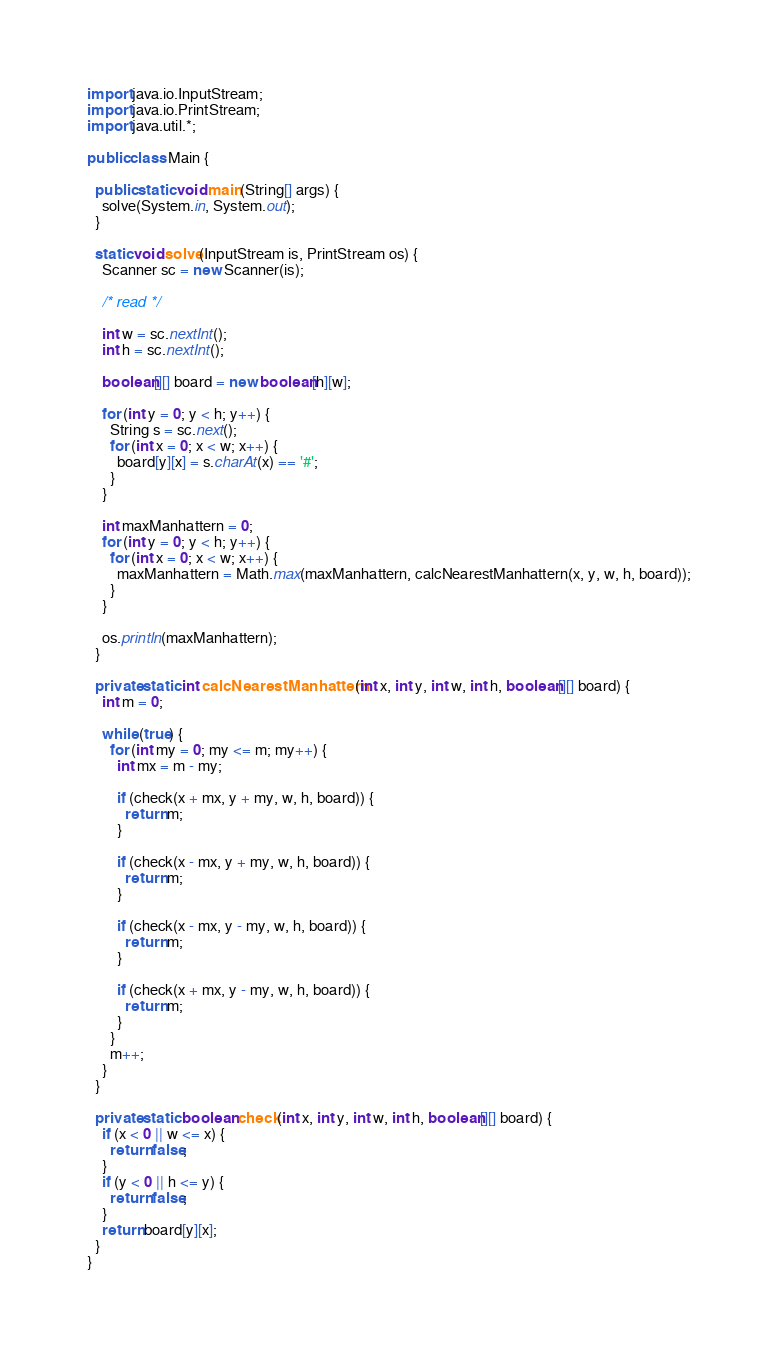<code> <loc_0><loc_0><loc_500><loc_500><_Java_>import java.io.InputStream;
import java.io.PrintStream;
import java.util.*;

public class Main {

  public static void main(String[] args) {
    solve(System.in, System.out);
  }

  static void solve(InputStream is, PrintStream os) {
    Scanner sc = new Scanner(is);

    /* read */

    int w = sc.nextInt();
    int h = sc.nextInt();

    boolean[][] board = new boolean[h][w];

    for (int y = 0; y < h; y++) {
      String s = sc.next();
      for (int x = 0; x < w; x++) {
        board[y][x] = s.charAt(x) == '#';
      }
    }

    int maxManhattern = 0;
    for (int y = 0; y < h; y++) {
      for (int x = 0; x < w; x++) {
        maxManhattern = Math.max(maxManhattern, calcNearestManhattern(x, y, w, h, board));
      }
    }

    os.println(maxManhattern);
  }

  private static int calcNearestManhattern(int x, int y, int w, int h, boolean[][] board) {
    int m = 0;

    while (true) {
      for (int my = 0; my <= m; my++) {
        int mx = m - my;

        if (check(x + mx, y + my, w, h, board)) {
          return m;
        }

        if (check(x - mx, y + my, w, h, board)) {
          return m;
        }

        if (check(x - mx, y - my, w, h, board)) {
          return m;
        }

        if (check(x + mx, y - my, w, h, board)) {
          return m;
        }
      }
      m++;
    }
  }

  private static boolean check(int x, int y, int w, int h, boolean[][] board) {
    if (x < 0 || w <= x) {
      return false;
    }
    if (y < 0 || h <= y) {
      return false;
    }
    return board[y][x];
  }
}</code> 